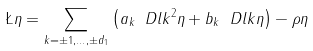<formula> <loc_0><loc_0><loc_500><loc_500>\L \eta = \sum _ { k = \pm 1 , \dots , \pm d _ { 1 } } \left ( a _ { k } \ D l k ^ { 2 } \eta + b _ { k } \ D l k \eta \right ) - \rho \eta</formula> 